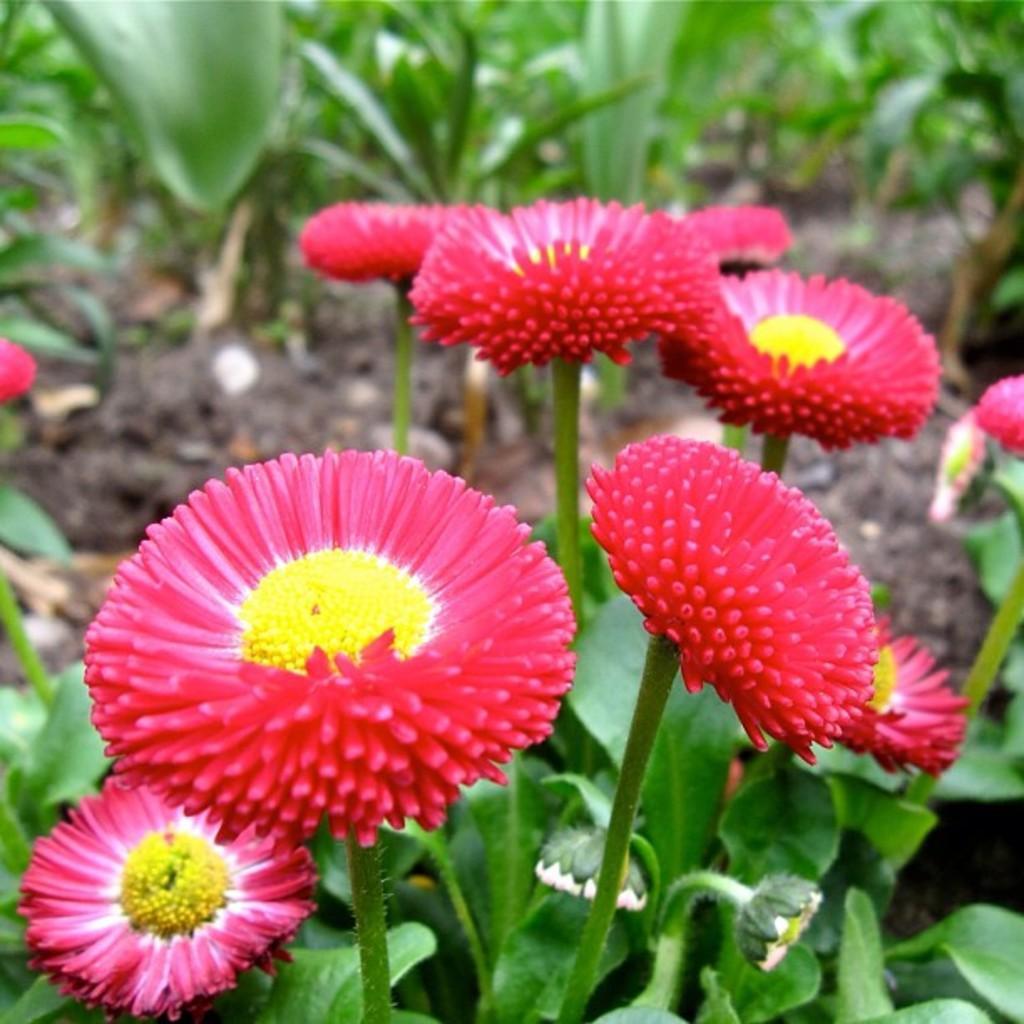Can you describe this image briefly? In this picture we can observe red and yellow color flowers. There are green color plants on the ground. 